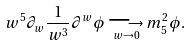<formula> <loc_0><loc_0><loc_500><loc_500>w ^ { 5 } \partial _ { w } \frac { 1 } { w ^ { 3 } } \partial ^ { w } \phi \underset { w \rightarrow 0 } { \longrightarrow } m _ { 5 } ^ { 2 } \phi .</formula> 